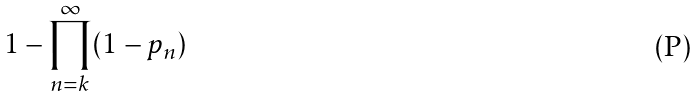<formula> <loc_0><loc_0><loc_500><loc_500>1 - \prod _ { n = k } ^ { \infty } ( 1 - p _ { n } )</formula> 